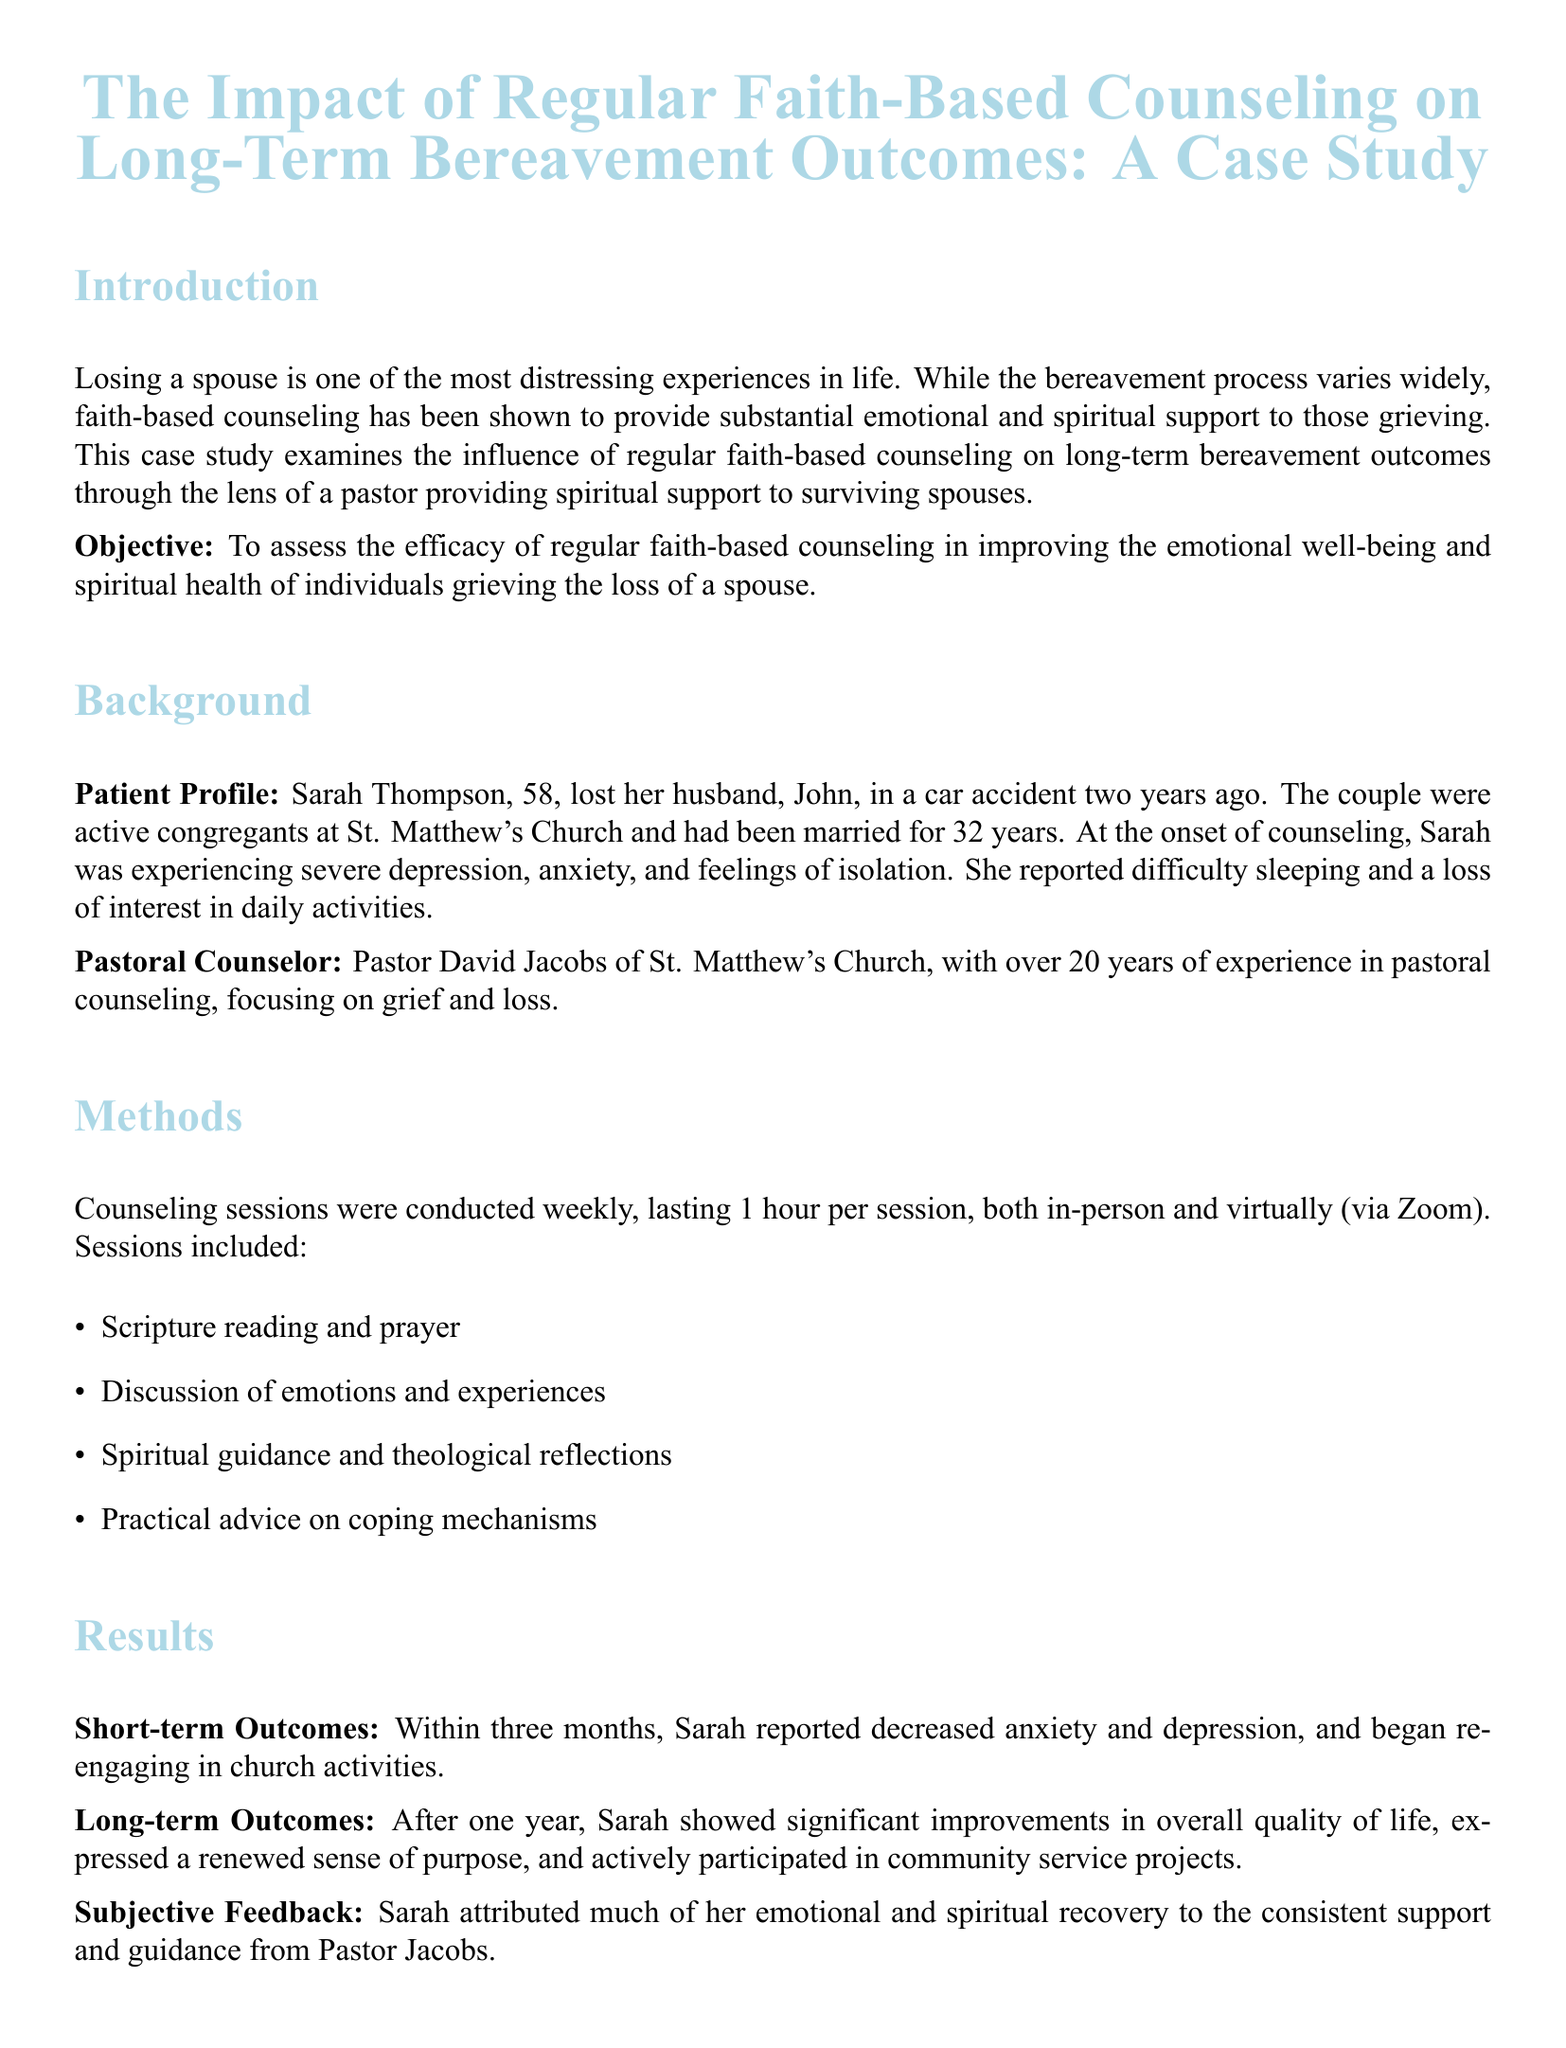What is the title of the case study? The title of the case study is indicated at the top of the document.
Answer: The Impact of Regular Faith-Based Counseling on Long-Term Bereavement Outcomes: A Case Study Who is the pastoral counselor mentioned in the study? The pastoral counselor's name is found in the "Pastoral Counselor" section of the document.
Answer: Pastor David Jacobs What was Sarah Thompson's age at the time of her husband's death? Sarah's age is specified in the "Patient Profile" section.
Answer: 58 How long had Sarah and John been married? The duration of their marriage is mentioned in the "Patient Profile" section.
Answer: 32 years What type of sessions were conducted in the counseling? The types of sessions are listed in the "Methods" section.
Answer: Weekly What was Sarah's emotional state at the onset of counseling? Sarah's initial emotional state can be found in the "Patient Profile" section.
Answer: Severe depression, anxiety, and feelings of isolation After how many months did Sarah report decreased anxiety and depression? The timeline for reported outcomes is detailed in the "Results" section.
Answer: Three months What aspect of life did Sarah show significant improvement in one year after counseling? The results of Sarah's transformation are reported under "Long-term Outcomes."
Answer: Overall quality of life 